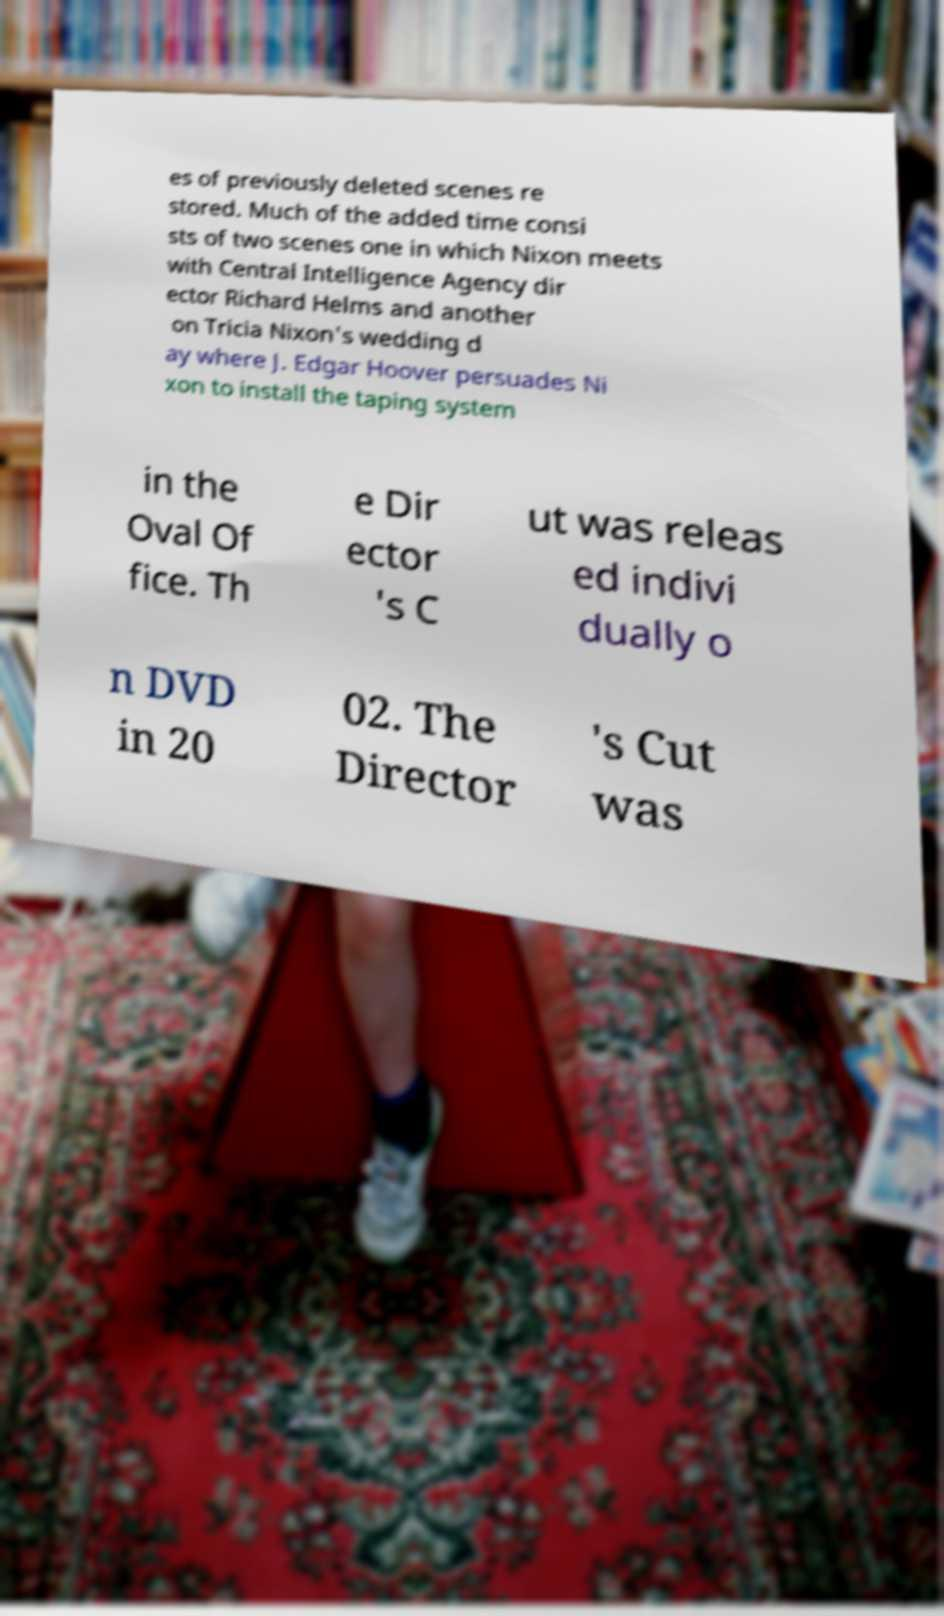Please read and relay the text visible in this image. What does it say? es of previously deleted scenes re stored. Much of the added time consi sts of two scenes one in which Nixon meets with Central Intelligence Agency dir ector Richard Helms and another on Tricia Nixon's wedding d ay where J. Edgar Hoover persuades Ni xon to install the taping system in the Oval Of fice. Th e Dir ector 's C ut was releas ed indivi dually o n DVD in 20 02. The Director 's Cut was 